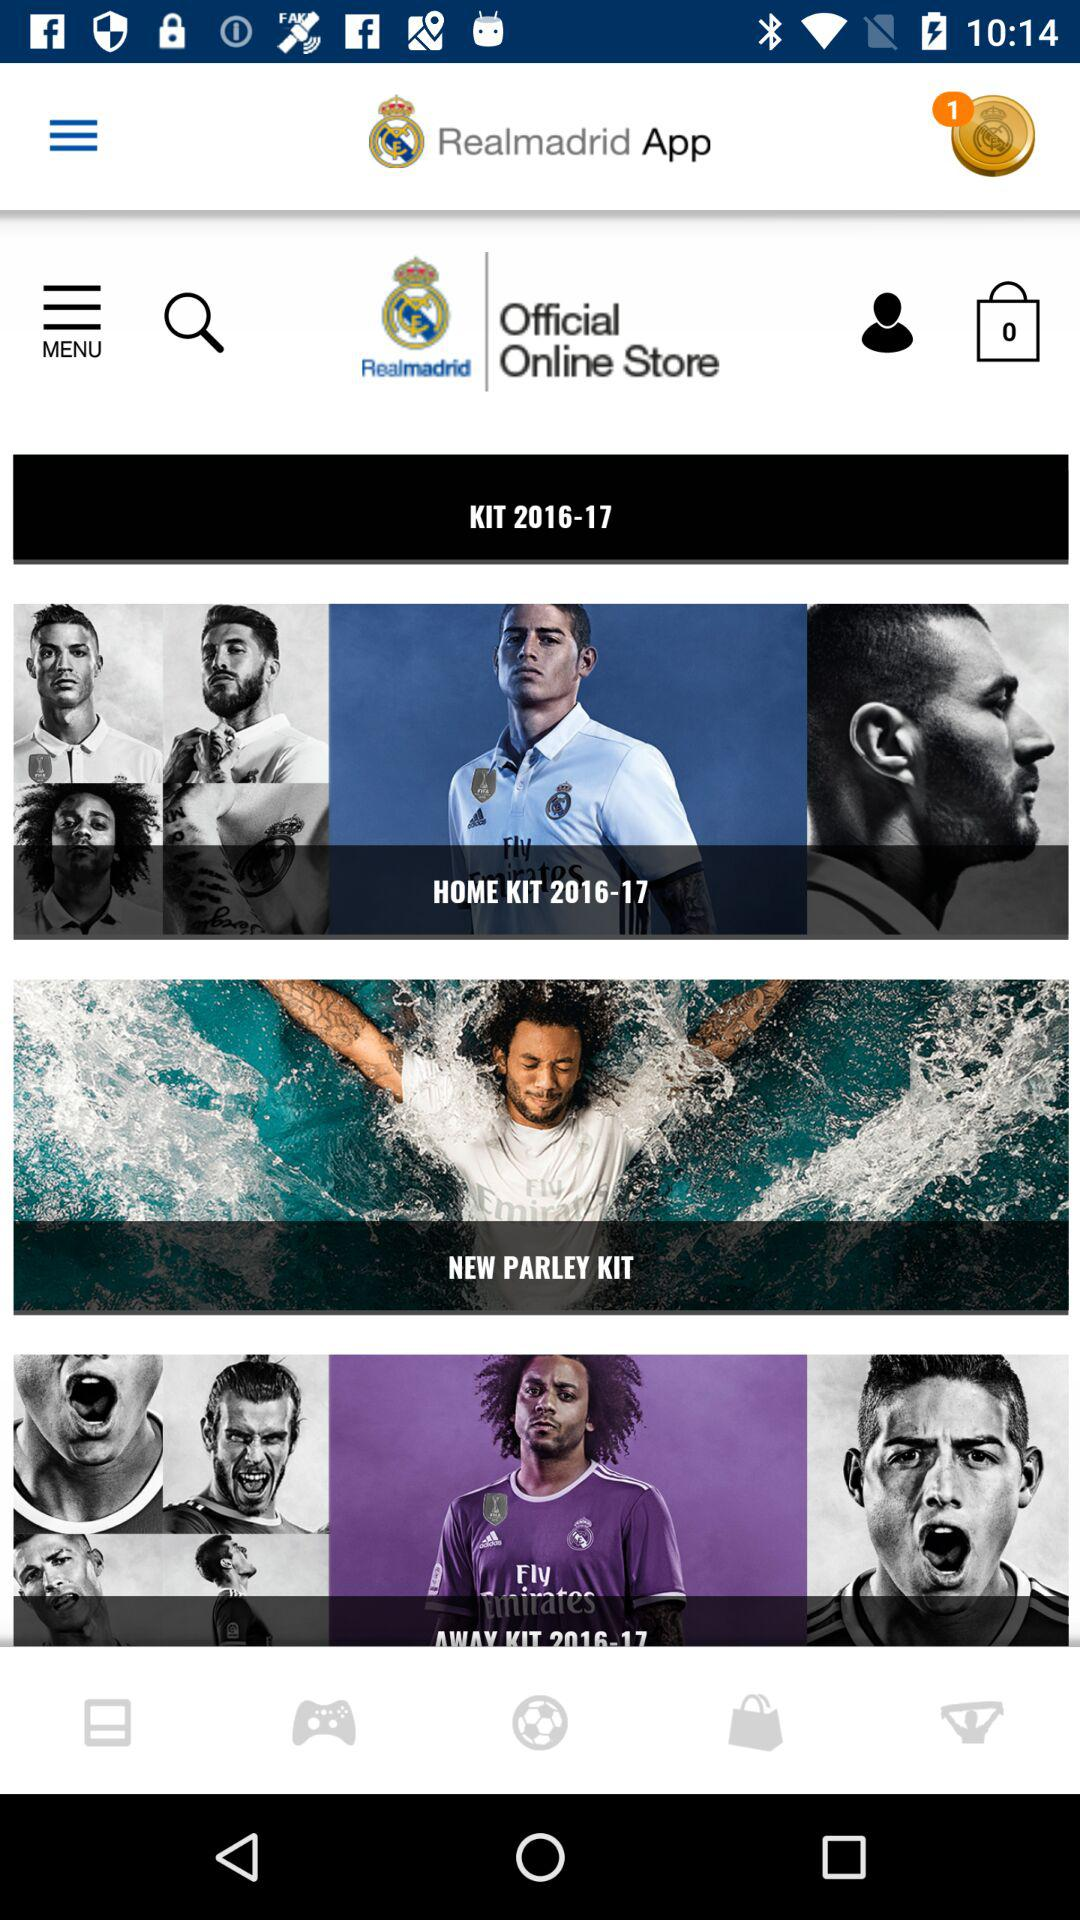What is the application name? The application name is "Realmadrid App". 